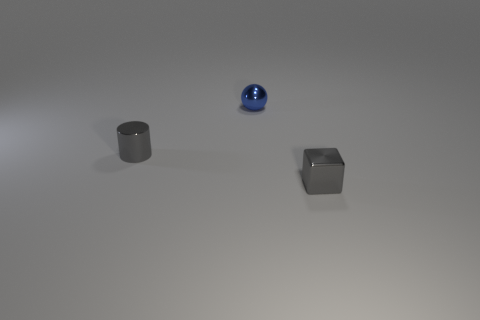There is a cube that is the same size as the blue metal object; what material is it?
Give a very brief answer. Metal. What number of other objects are there of the same size as the gray block?
Your answer should be compact. 2. What number of small cylinders have the same color as the cube?
Keep it short and to the point. 1. What shape is the blue metal thing?
Give a very brief answer. Sphere. What color is the tiny thing that is both right of the small metallic cylinder and behind the small gray cube?
Offer a very short reply. Blue. What is the material of the small ball?
Make the answer very short. Metal. There is a tiny gray thing in front of the metal cylinder; what is its shape?
Make the answer very short. Cube. What is the color of the metal block that is the same size as the metal cylinder?
Give a very brief answer. Gray. Is the small object behind the tiny gray cylinder made of the same material as the gray cylinder?
Your response must be concise. Yes. What is the size of the object that is both in front of the tiny blue shiny thing and to the right of the cylinder?
Offer a terse response. Small. 